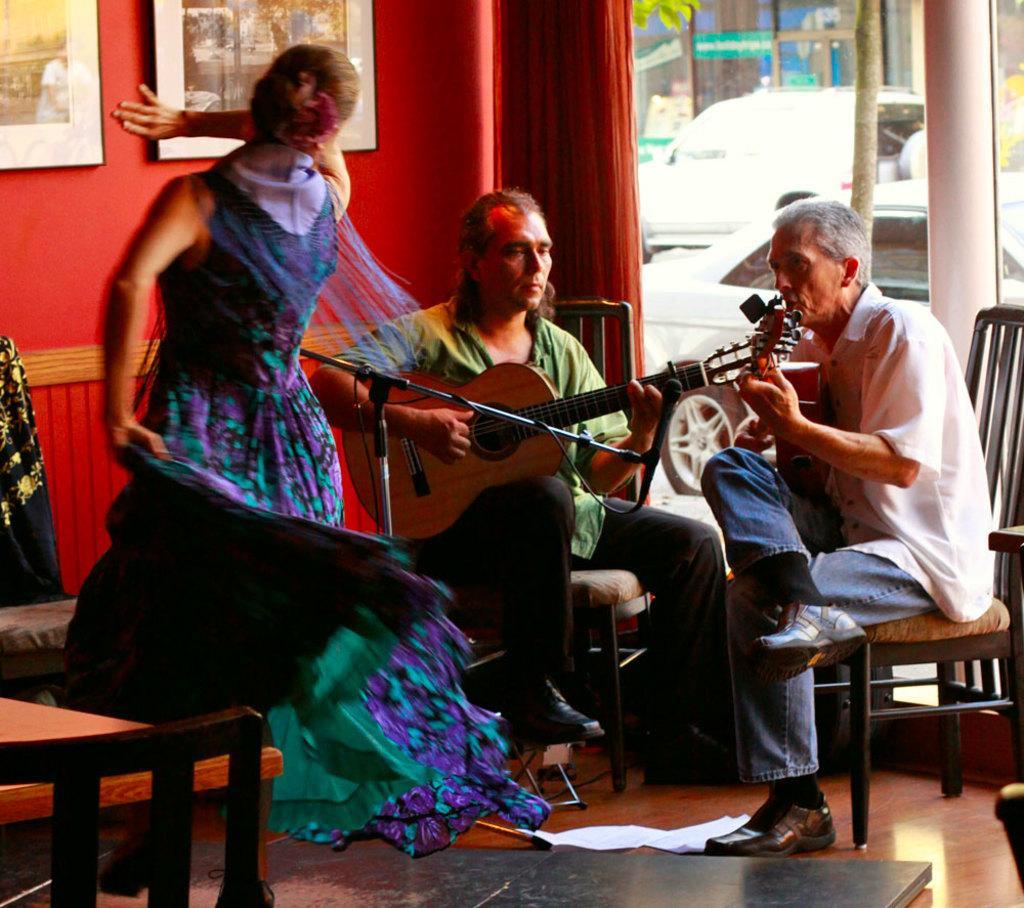In one or two sentences, can you explain what this image depicts? 2 people are sitting and playing guitar. a person in front of them is dancing. behind them there is a red wall on which there are photo frames. 